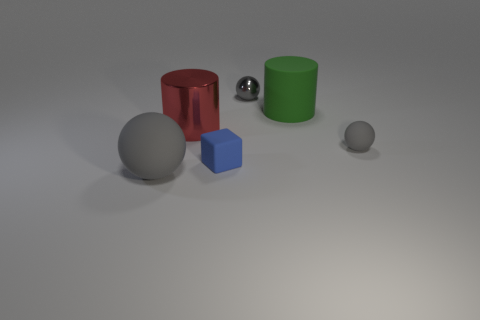Subtract all gray balls. How many were subtracted if there are1gray balls left? 2 Subtract all gray matte spheres. How many spheres are left? 1 Add 3 large rubber spheres. How many objects exist? 9 Add 2 tiny objects. How many tiny objects exist? 5 Subtract 0 red spheres. How many objects are left? 6 Subtract all cylinders. How many objects are left? 4 Subtract all large purple rubber objects. Subtract all big gray things. How many objects are left? 5 Add 4 shiny objects. How many shiny objects are left? 6 